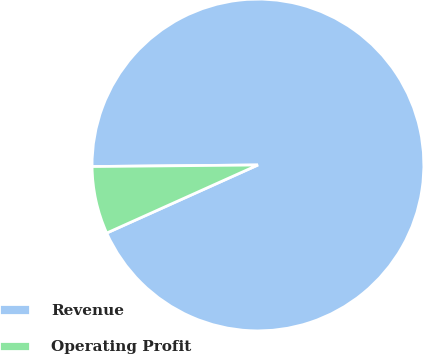Convert chart to OTSL. <chart><loc_0><loc_0><loc_500><loc_500><pie_chart><fcel>Revenue<fcel>Operating Profit<nl><fcel>93.42%<fcel>6.58%<nl></chart> 